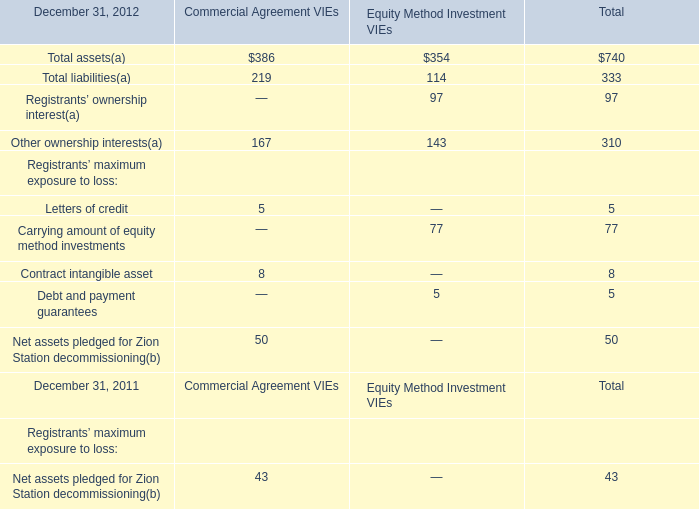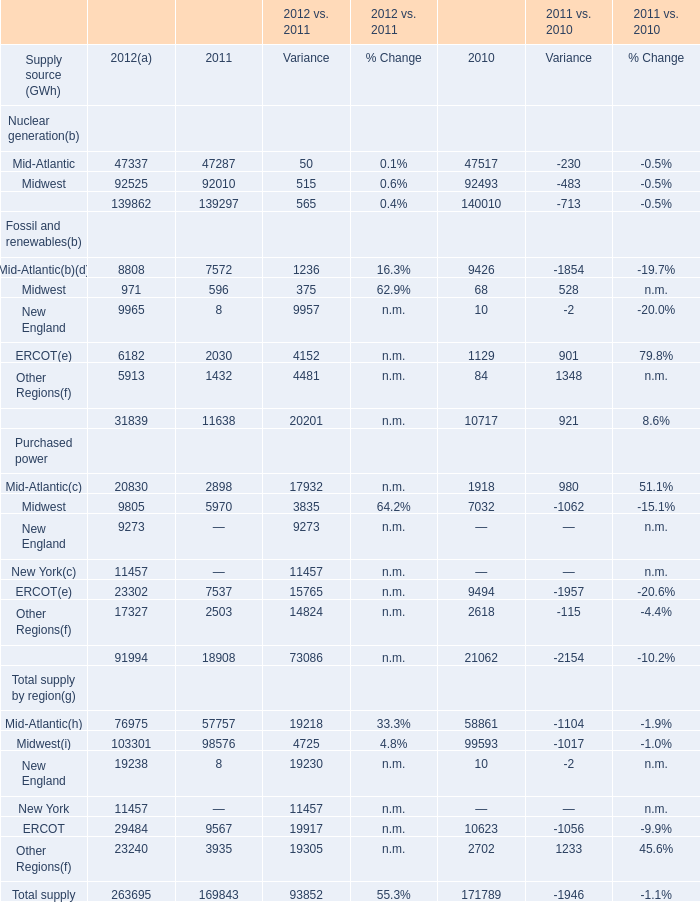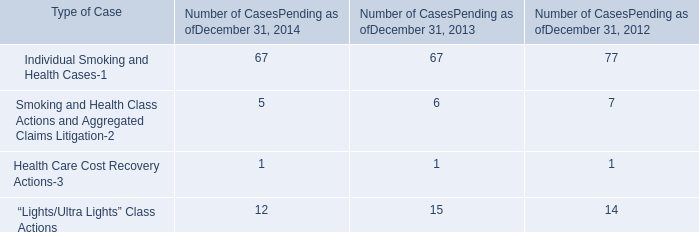What is the increasing rate of Total supply between 2011 and 2012? 
Computations: ((263695 - 169843) / 169843)
Answer: 0.55258. 